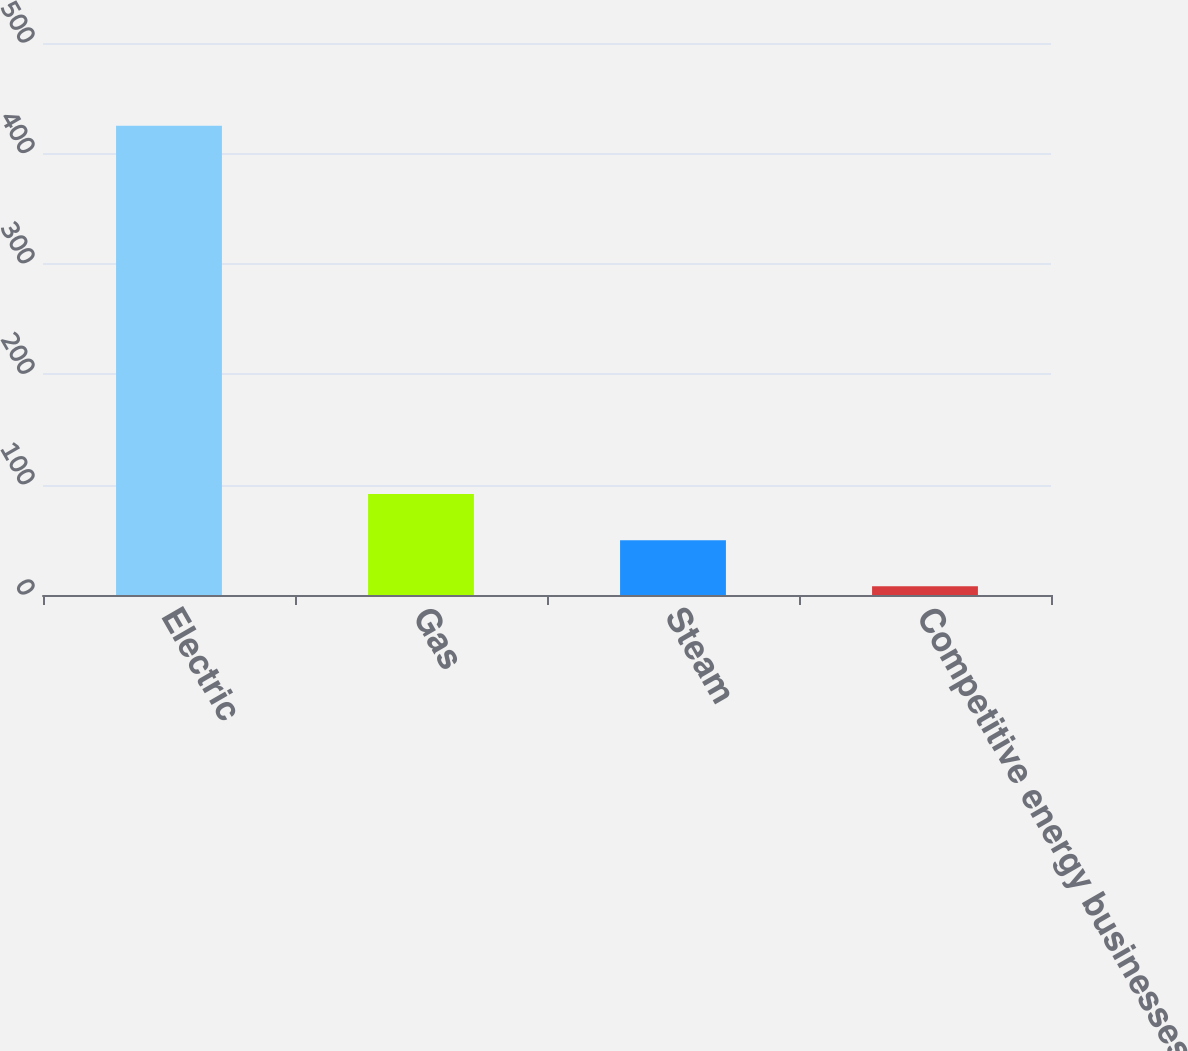<chart> <loc_0><loc_0><loc_500><loc_500><bar_chart><fcel>Electric<fcel>Gas<fcel>Steam<fcel>Competitive energy businesses<nl><fcel>425<fcel>91.4<fcel>49.7<fcel>8<nl></chart> 